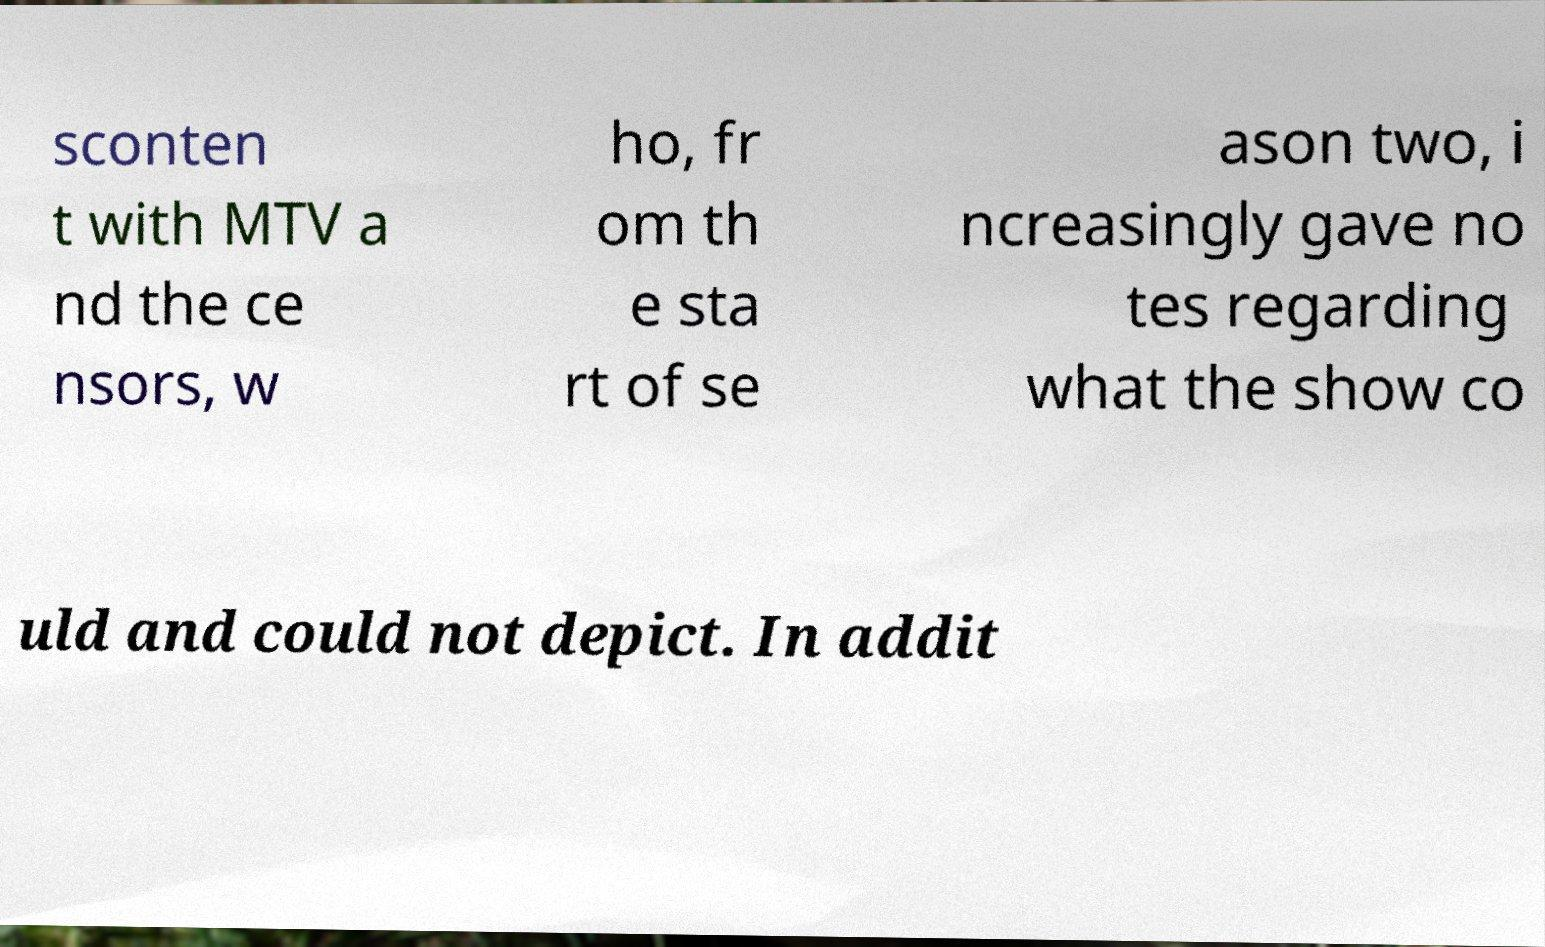For documentation purposes, I need the text within this image transcribed. Could you provide that? sconten t with MTV a nd the ce nsors, w ho, fr om th e sta rt of se ason two, i ncreasingly gave no tes regarding what the show co uld and could not depict. In addit 